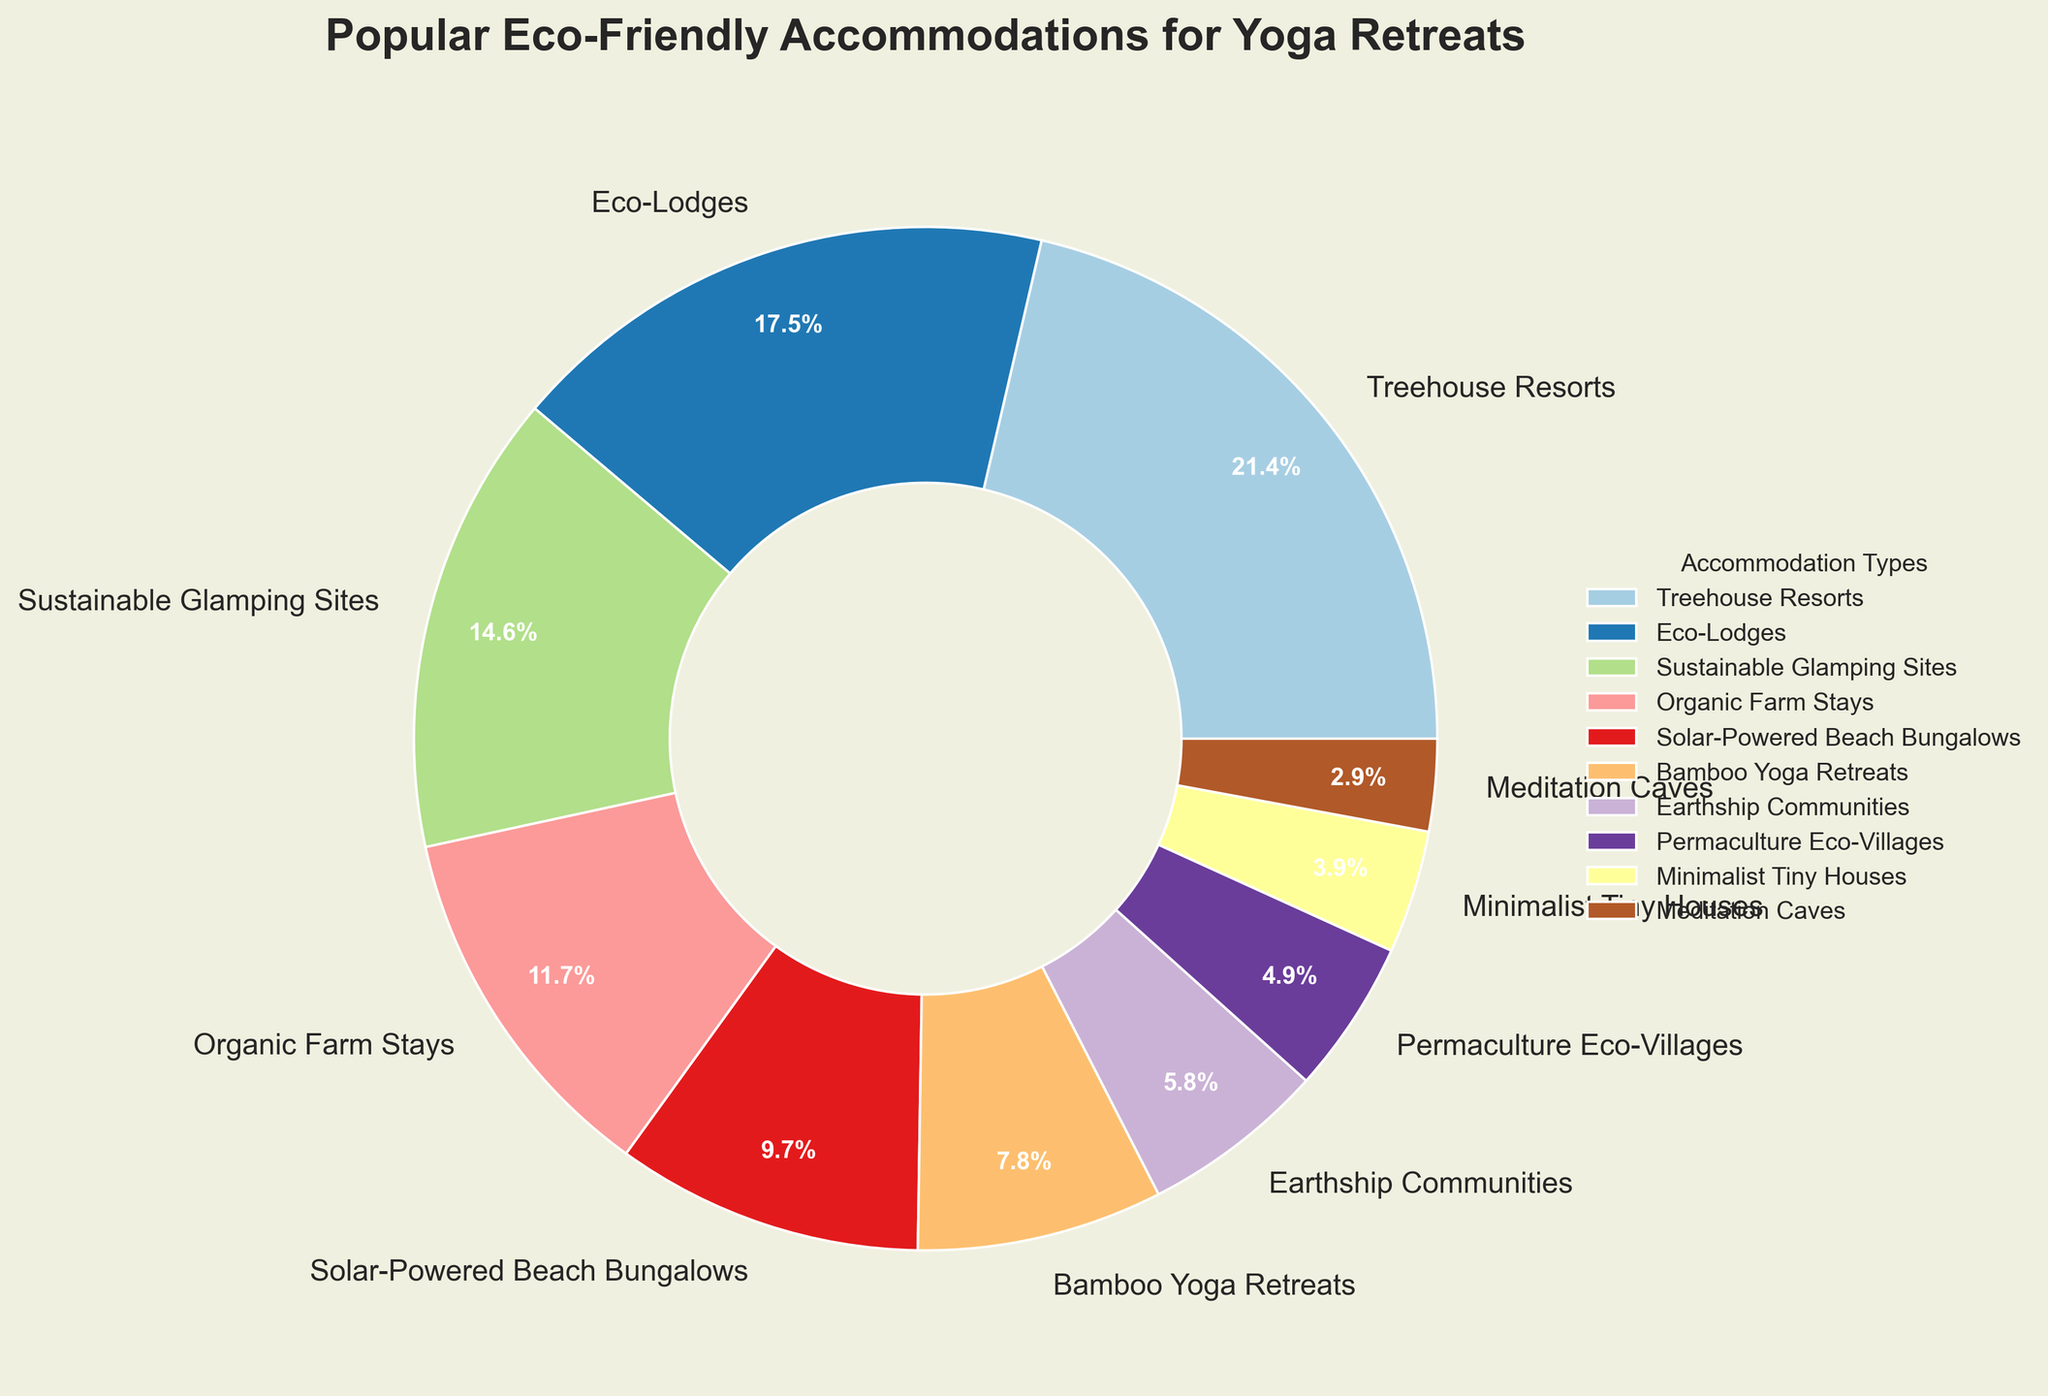Which accommodation type is the most popular among yoga retreat participants? The most popular accommodation type can be identified by the largest slice in the pie chart. The "Treehouse Resorts" slice is the largest.
Answer: Treehouse Resorts Which is more popular, Solar-Powered Beach Bungalows or Organic Farm Stays? Compare the size of the slices for Solar-Powered Beach Bungalows and Organic Farm Stays. The percentage for Solar-Powered Beach Bungalows is 10%, while for Organic Farm Stays it is 12%.
Answer: Organic Farm Stays What is the total percentage of participants that chose Bamboo Yoga Retreats and Meditation Caves combined? Add the percentages for Bamboo Yoga Retreats and Meditation Caves: 8% + 3% = 11%
Answer: 11% How many accommodation types have a percentage less than 10%? Count the number of slices that represent percentages less than 10%: Bamboo Yoga Retreats (8%), Earthship Communities (6%), Permaculture Eco-Villages (5%), Minimalist Tiny Houses (4%), Meditation Caves (3%).
Answer: 5 Which accommodation type occupies a wedge with a similar color to the "Treehouse Resorts" slice but smaller in size? Identify wedges with similar colors to the "Treehouse Resorts" slice and compare their sizes, excluding the largest slice. The slice for “Eco-Lodges” has a similar color but is smaller at 18%.
Answer: Eco-Lodges Are Sustainable Glamping Sites more popular than Earthship Communities and Permaculture Eco-Villages combined? Compare the percentages: Sustainable Glamping Sites (15%) vs. Earthship Communities (6%) + Permaculture Eco-Villages (5%) = 11%. 15% is greater than 11%.
Answer: Yes Which accommodation type represents the smallest percentage of yoga retreat participants? The smallest slice in the pie chart represents the accommodation type with the smallest percentage, which in this case is "Meditation Caves" at 3%.
Answer: Meditation Caves What is the combined percentage of the three least popular accommodation types? Add the percentages of the three least popular accommodation types: Meditation Caves (3%), Minimalist Tiny Houses (4%), Permaculture Eco-Villages (5%), which equals 3% + 4% + 5% = 12%.
Answer: 12% Which two accommodation types together make up exactly 20% of the participants? Identify pair combinations from the pie chart that sum to 20%. Solar-Powered Beach Bungalows (10%) and Minimalist Tiny Houses (4%) do not sum to 20%. Instead, Organic Farm Stays (12%) and Bamboo Yoga Retreats (8%) sum to 20%.
Answer: Organic Farm Stays and Bamboo Yoga Retreats Is the wedge labeled "Eco-Lodges" larger or smaller than the wedge labeled "Treehouse Resorts"? Visually compare the sizes of the slices; "Treehouse Resorts" at 22% is larger than "Eco-Lodges" at 18%.
Answer: Smaller 